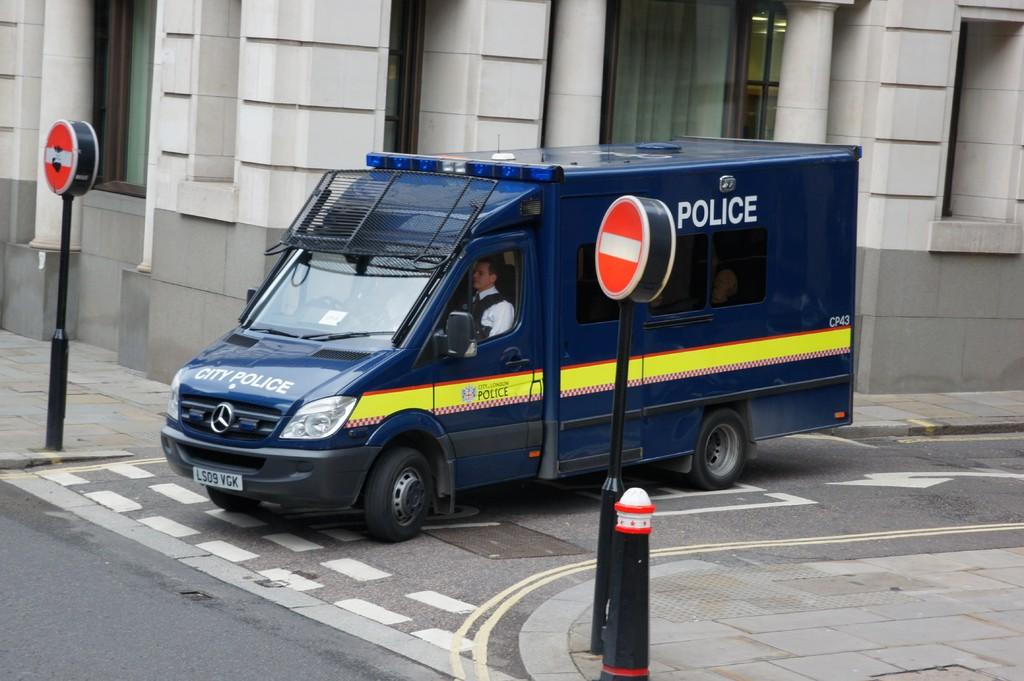What kind of agency uses this truck?
Provide a short and direct response. Police. What is the van's license plate number?
Keep it short and to the point. Ls09 vgk. 